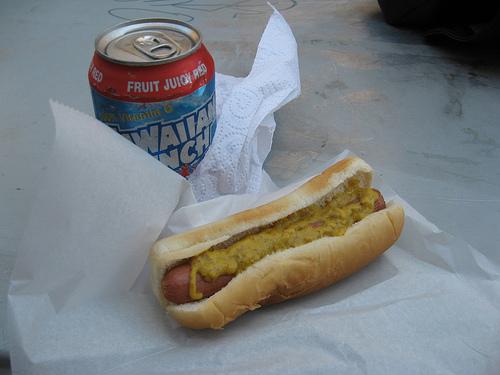Does the hot dog's bun have poppy seeds on it?
Keep it brief. No. Is there a drink in this picture?
Quick response, please. Yes. Does this hot dog have a bite taken out of it?
Write a very short answer. No. Is the meal gluten free?
Keep it brief. No. Are there a variety of hot dogs?
Concise answer only. No. What does the P stand for?
Be succinct. Punch. What is on the hotdog?
Quick response, please. Mustard. What kind of drink is this?
Concise answer only. Hawaiian punch. How many condiments are on the hot dog?
Be succinct. 1. Shouldn't there be some ketchup on this hot dog?
Write a very short answer. Yes. Is this a lunch for one person?
Write a very short answer. Yes. What condiments are on the hot dog?
Answer briefly. Mustard. What is the brand of the soda?
Write a very short answer. Hawaiian punch. What state is the can from?
Concise answer only. Hawaii. What condiment is on top of the hot dog?
Short answer required. Mustard. Is the meal safe for a toddler to eat?
Be succinct. No. What type of  container is the drink in?
Answer briefly. Can. How many different types of buns do count?
Concise answer only. 1. How many hot dogs are there?
Answer briefly. 1. 